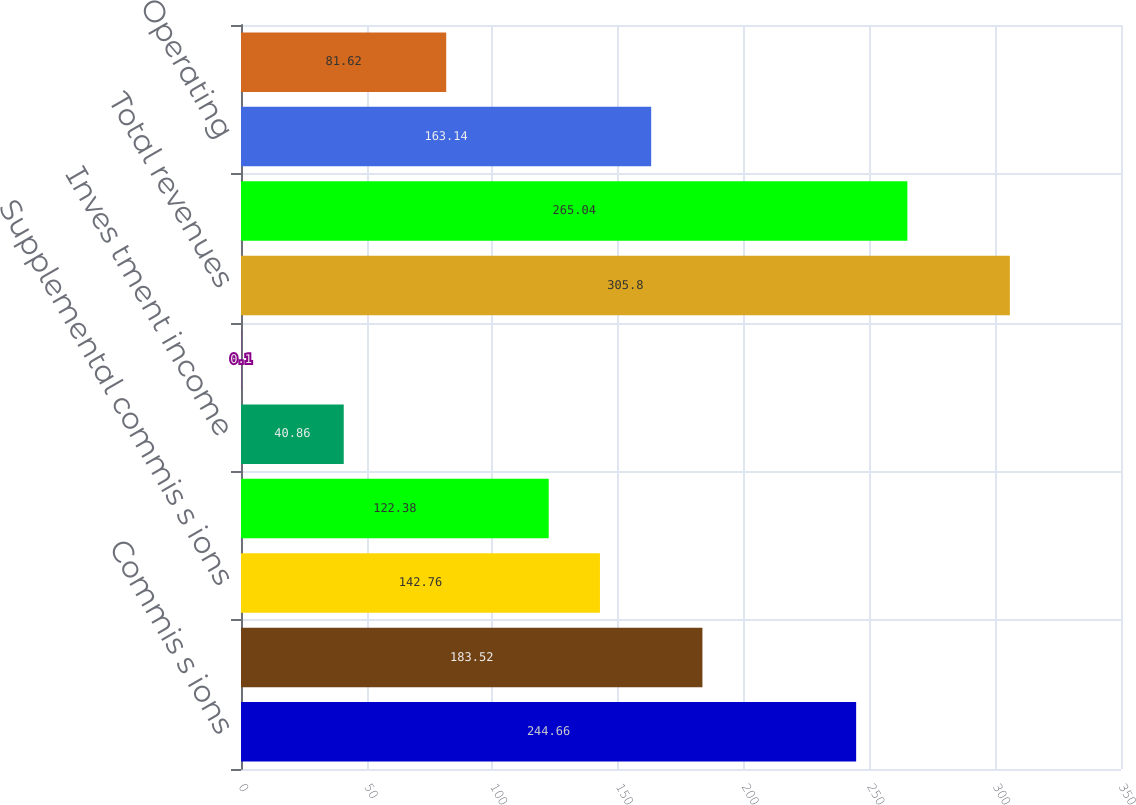<chart> <loc_0><loc_0><loc_500><loc_500><bar_chart><fcel>Commis s ions<fcel>Fees<fcel>Supplemental commis s ions<fcel>Contingent commis s ions<fcel>Inves tment income<fcel>Gains realized on books<fcel>Total revenues<fcel>Compens ation<fcel>Operating<fcel>Depreciation<nl><fcel>244.66<fcel>183.52<fcel>142.76<fcel>122.38<fcel>40.86<fcel>0.1<fcel>305.8<fcel>265.04<fcel>163.14<fcel>81.62<nl></chart> 